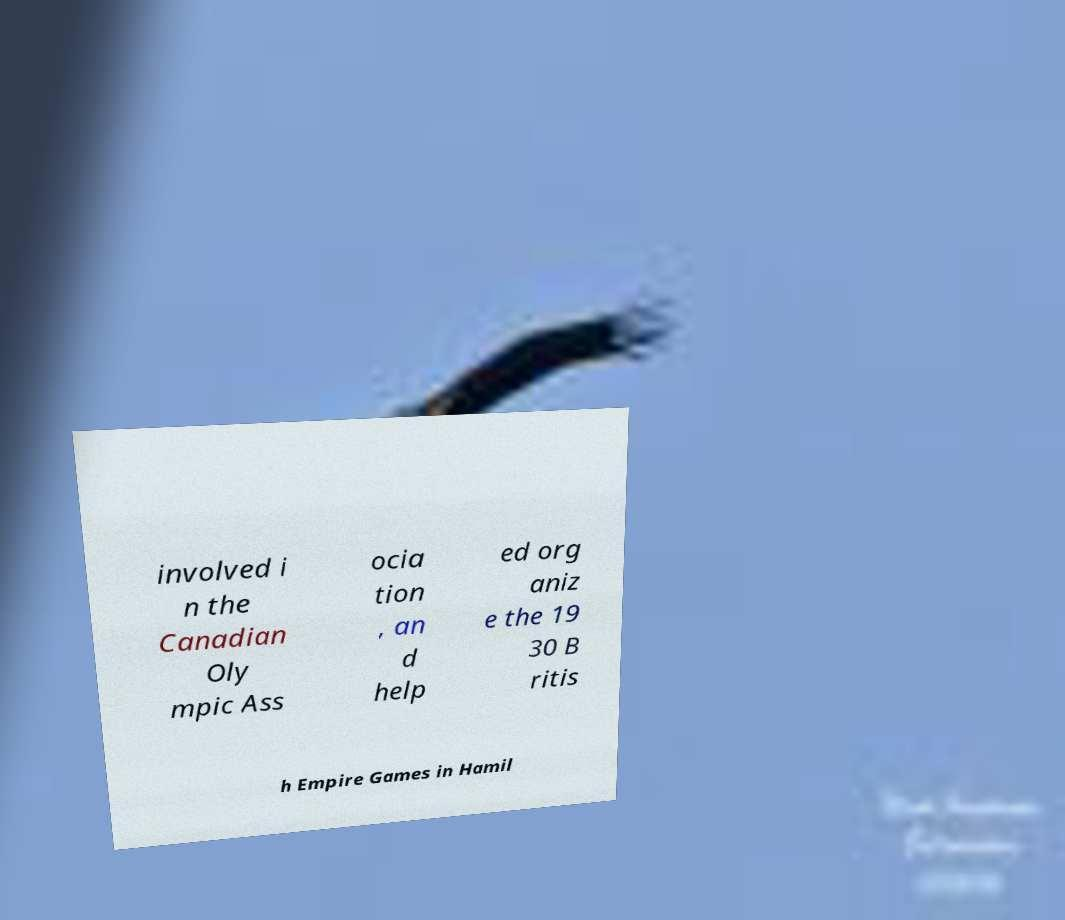For documentation purposes, I need the text within this image transcribed. Could you provide that? involved i n the Canadian Oly mpic Ass ocia tion , an d help ed org aniz e the 19 30 B ritis h Empire Games in Hamil 